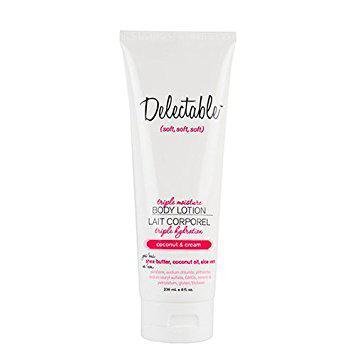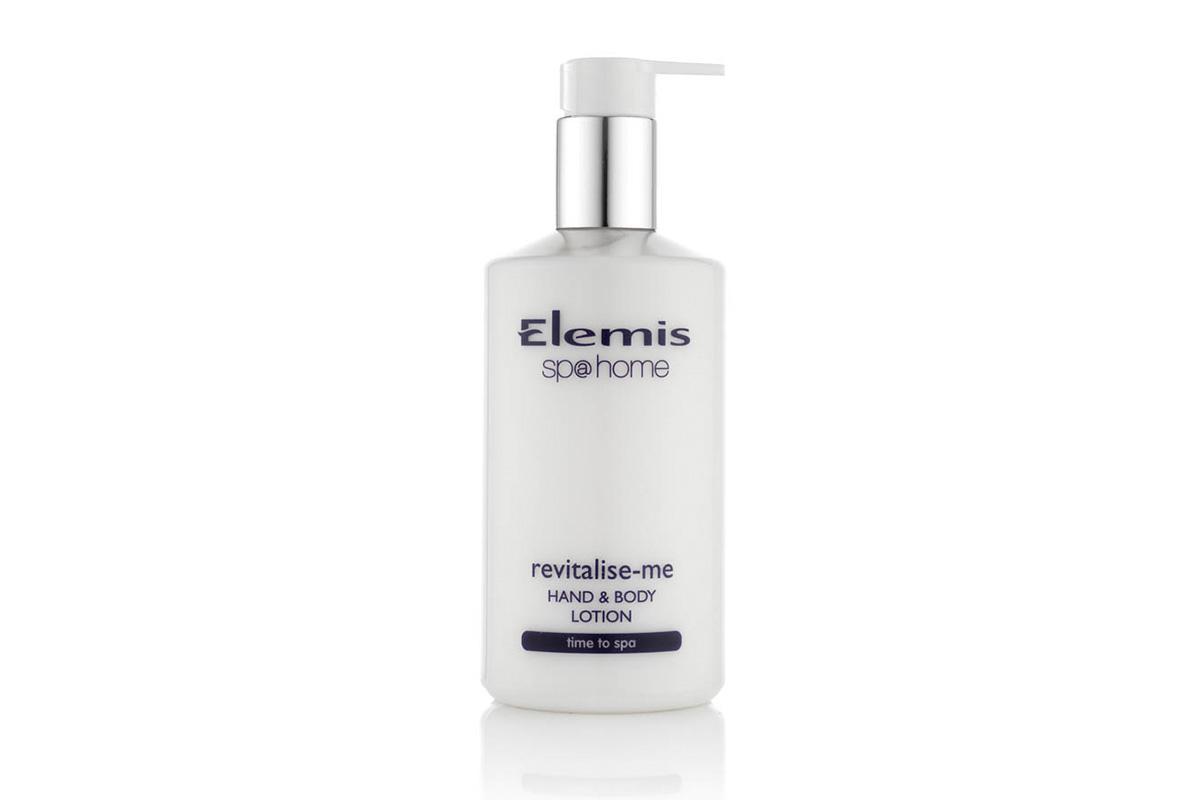The first image is the image on the left, the second image is the image on the right. For the images shown, is this caption "One image shows the finger of one hand pressing the top of a white bottle to squirt lotion on another hand." true? Answer yes or no. No. The first image is the image on the left, the second image is the image on the right. For the images displayed, is the sentence "The left and right image contains the same number of closed lotion bottles." factually correct? Answer yes or no. Yes. 